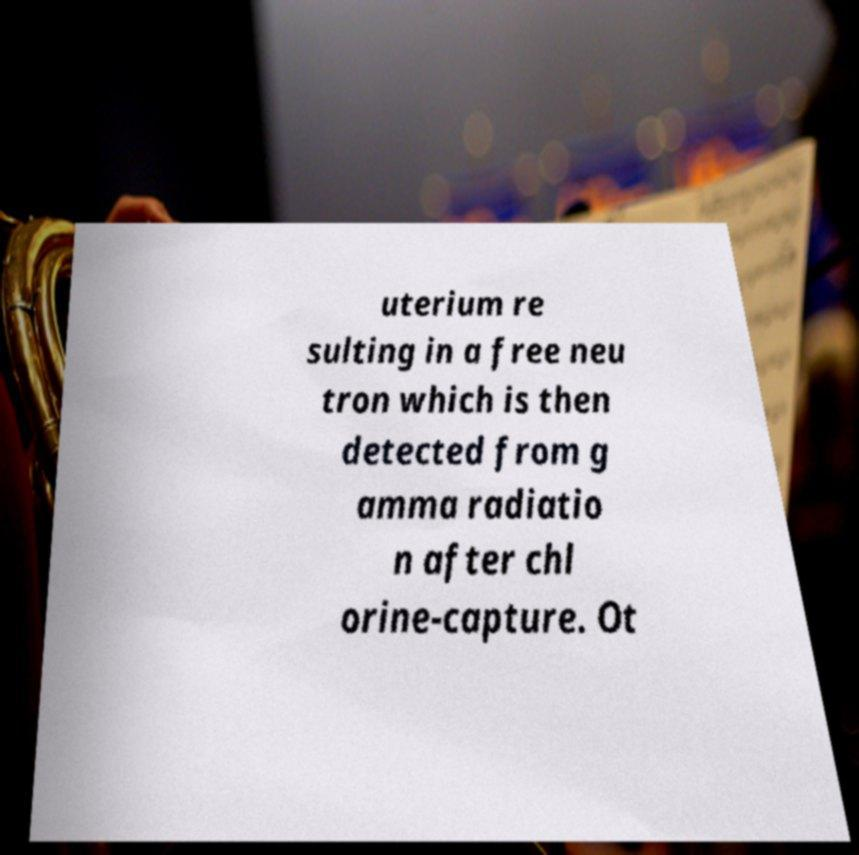Please identify and transcribe the text found in this image. uterium re sulting in a free neu tron which is then detected from g amma radiatio n after chl orine-capture. Ot 